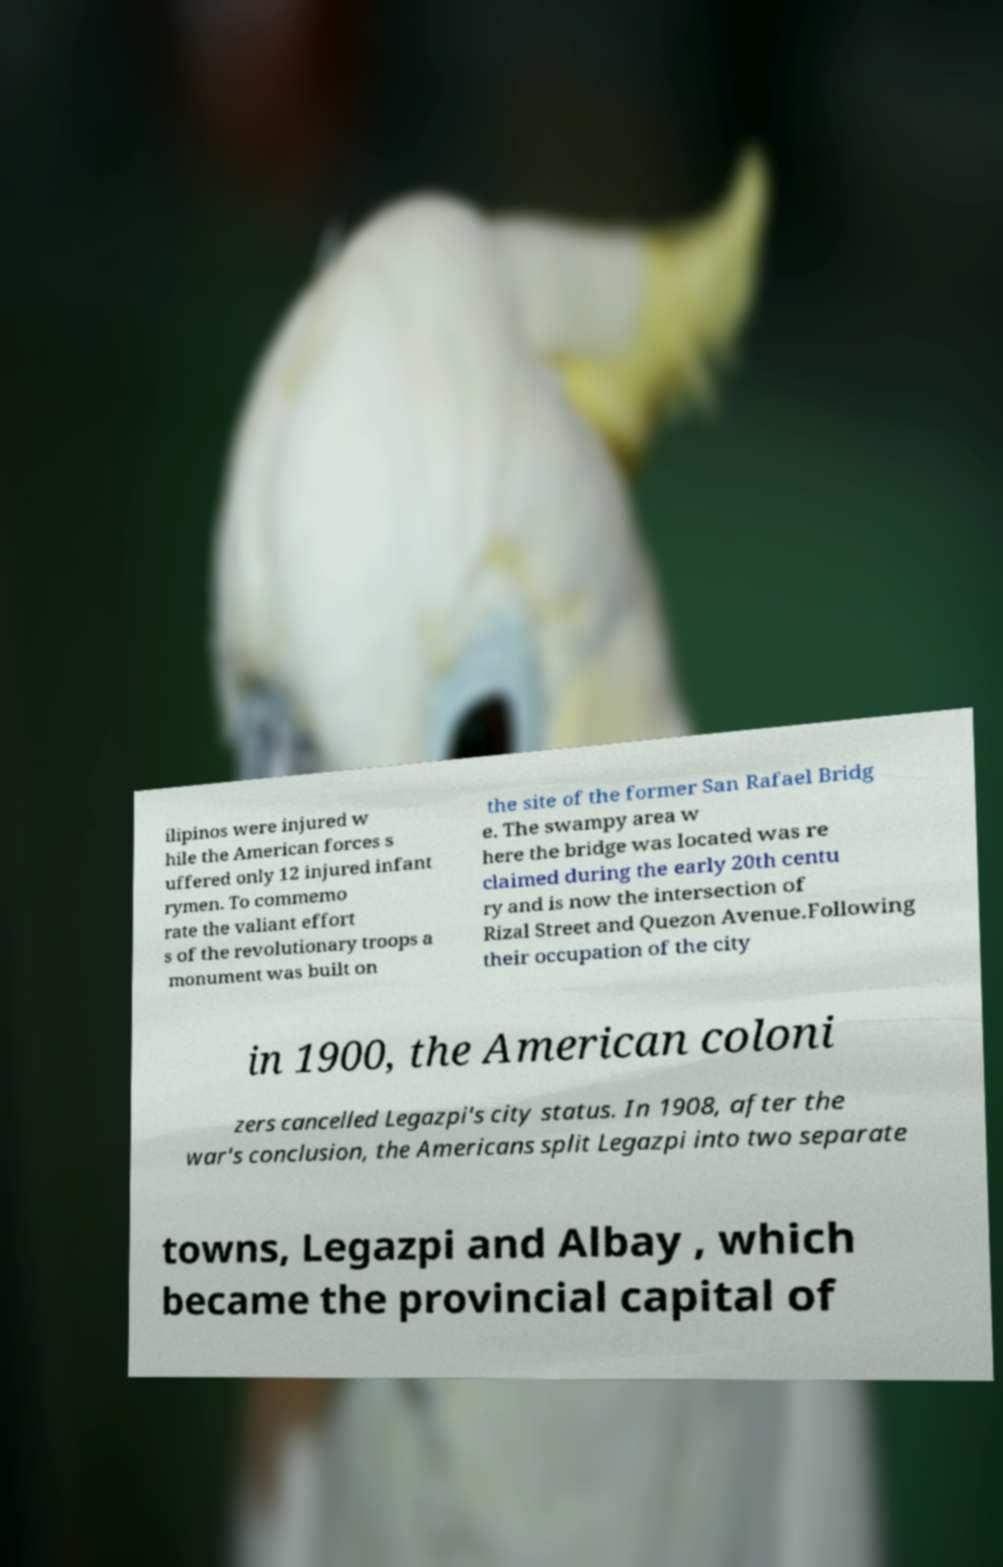Can you accurately transcribe the text from the provided image for me? ilipinos were injured w hile the American forces s uffered only 12 injured infant rymen. To commemo rate the valiant effort s of the revolutionary troops a monument was built on the site of the former San Rafael Bridg e. The swampy area w here the bridge was located was re claimed during the early 20th centu ry and is now the intersection of Rizal Street and Quezon Avenue.Following their occupation of the city in 1900, the American coloni zers cancelled Legazpi's city status. In 1908, after the war's conclusion, the Americans split Legazpi into two separate towns, Legazpi and Albay , which became the provincial capital of 